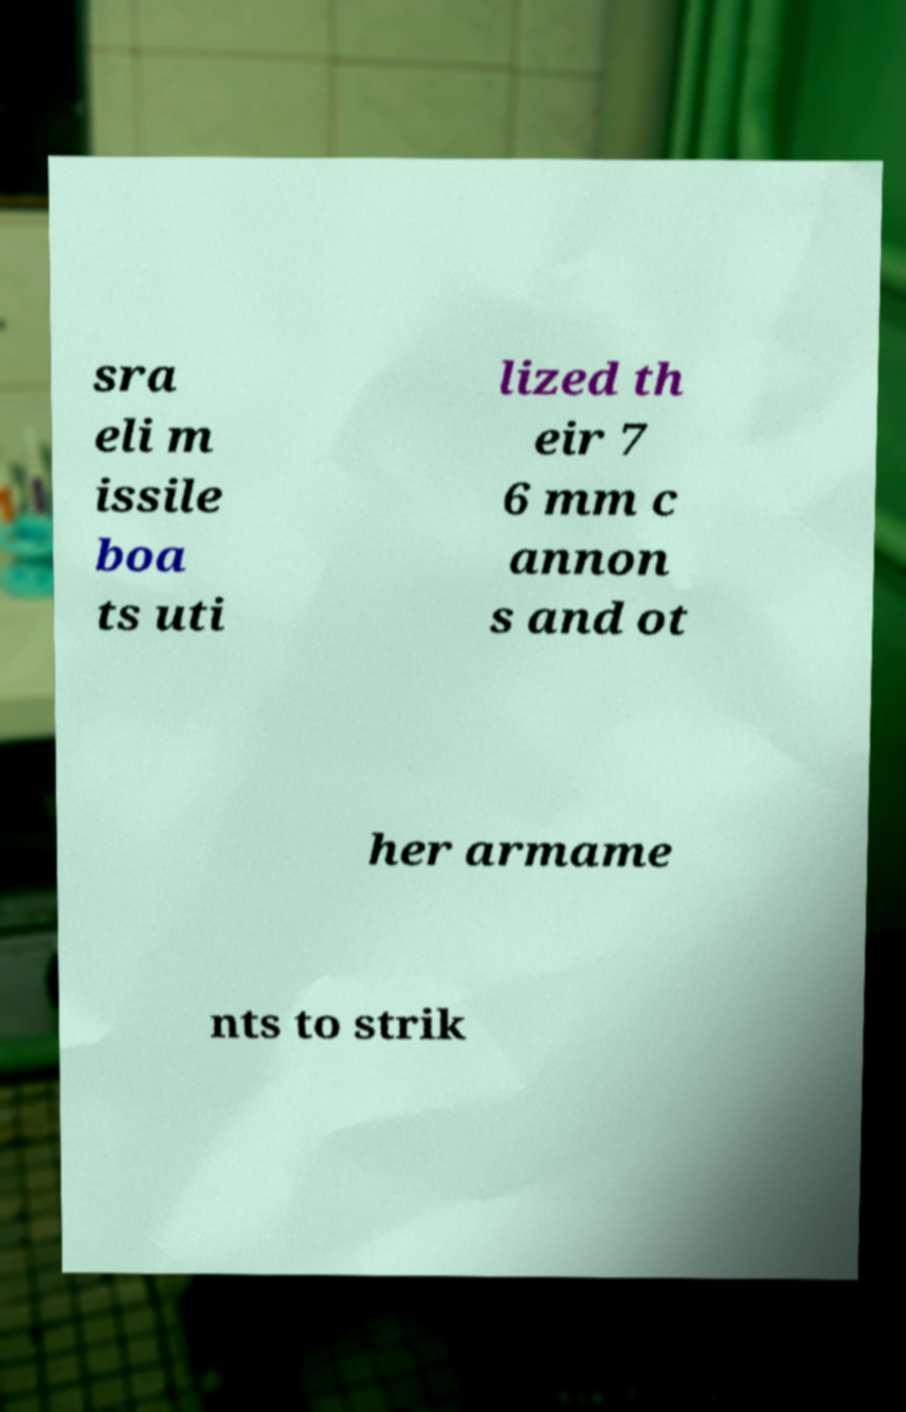For documentation purposes, I need the text within this image transcribed. Could you provide that? sra eli m issile boa ts uti lized th eir 7 6 mm c annon s and ot her armame nts to strik 